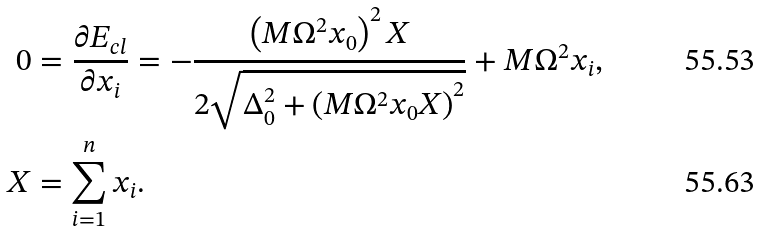Convert formula to latex. <formula><loc_0><loc_0><loc_500><loc_500>0 & = \frac { \partial E _ { c l } } { \partial x _ { i } } = - \frac { \left ( M \Omega ^ { 2 } x _ { 0 } \right ) ^ { 2 } X } { 2 \sqrt { \Delta _ { 0 } ^ { 2 } + \left ( M \Omega ^ { 2 } x _ { 0 } X \right ) ^ { 2 } } } + M \Omega ^ { 2 } x _ { i } , \\ X & = \sum _ { i = 1 } ^ { n } x _ { i } .</formula> 